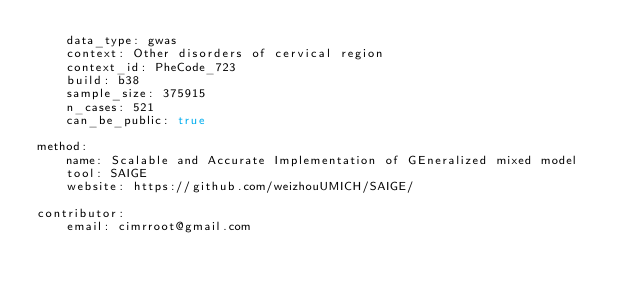<code> <loc_0><loc_0><loc_500><loc_500><_YAML_>    data_type: gwas
    context: Other disorders of cervical region
    context_id: PheCode_723
    build: b38
    sample_size: 375915
    n_cases: 521
    can_be_public: true

method:
    name: Scalable and Accurate Implementation of GEneralized mixed model
    tool: SAIGE
    website: https://github.com/weizhouUMICH/SAIGE/

contributor:
    email: cimrroot@gmail.com

</code> 